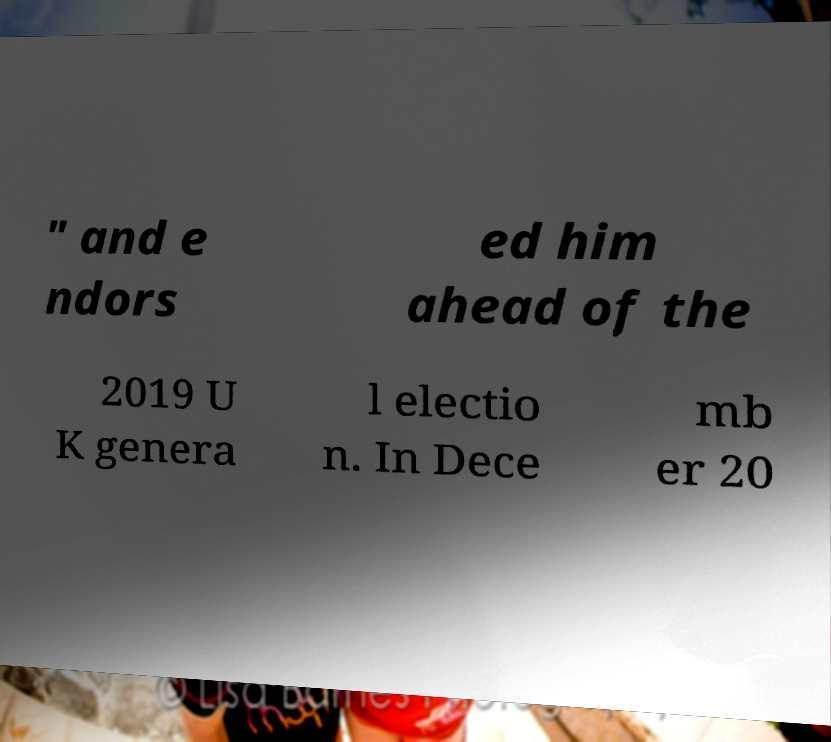Can you accurately transcribe the text from the provided image for me? " and e ndors ed him ahead of the 2019 U K genera l electio n. In Dece mb er 20 